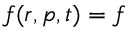Convert formula to latex. <formula><loc_0><loc_0><loc_500><loc_500>f ( r , p , t ) = f</formula> 